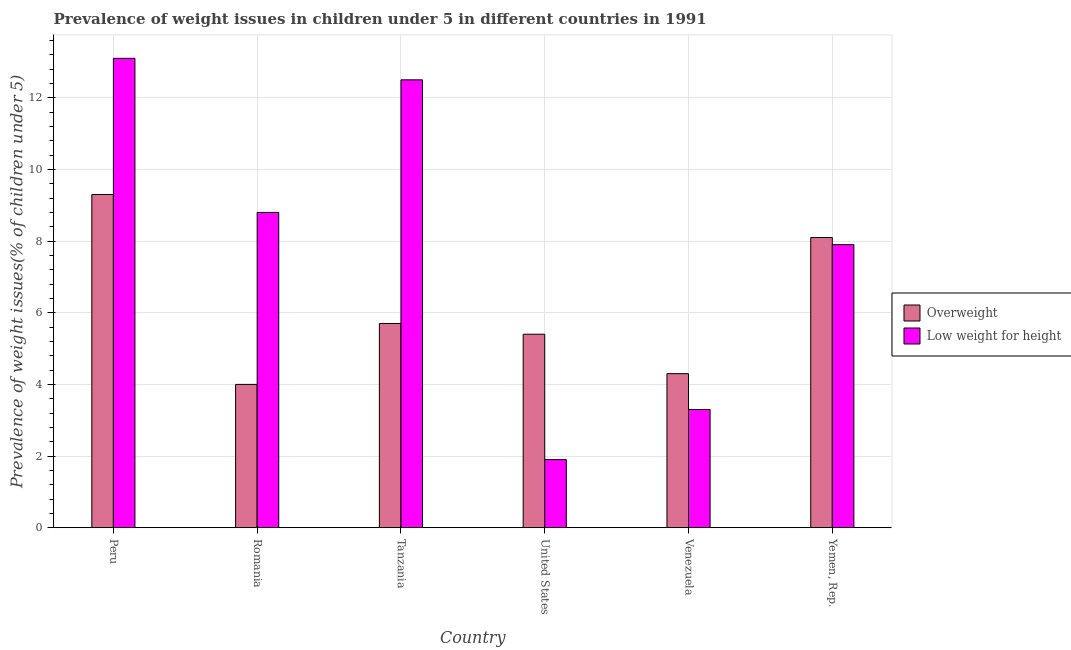How many different coloured bars are there?
Offer a terse response. 2. How many groups of bars are there?
Your response must be concise. 6. Are the number of bars per tick equal to the number of legend labels?
Your answer should be compact. Yes. Are the number of bars on each tick of the X-axis equal?
Your answer should be very brief. Yes. How many bars are there on the 1st tick from the right?
Your answer should be compact. 2. What is the label of the 6th group of bars from the left?
Keep it short and to the point. Yemen, Rep. In how many cases, is the number of bars for a given country not equal to the number of legend labels?
Your response must be concise. 0. What is the percentage of underweight children in Yemen, Rep.?
Your response must be concise. 7.9. Across all countries, what is the maximum percentage of overweight children?
Ensure brevity in your answer.  9.3. Across all countries, what is the minimum percentage of underweight children?
Ensure brevity in your answer.  1.9. In which country was the percentage of overweight children minimum?
Provide a short and direct response. Romania. What is the total percentage of underweight children in the graph?
Your answer should be very brief. 47.5. What is the difference between the percentage of underweight children in Romania and that in Tanzania?
Your answer should be very brief. -3.7. What is the difference between the percentage of overweight children in Peru and the percentage of underweight children in Yemen, Rep.?
Offer a terse response. 1.4. What is the average percentage of underweight children per country?
Offer a very short reply. 7.92. What is the difference between the percentage of underweight children and percentage of overweight children in Tanzania?
Make the answer very short. 6.8. What is the ratio of the percentage of overweight children in Romania to that in Tanzania?
Ensure brevity in your answer.  0.7. What is the difference between the highest and the second highest percentage of underweight children?
Provide a succinct answer. 0.6. What is the difference between the highest and the lowest percentage of overweight children?
Offer a very short reply. 5.3. What does the 1st bar from the left in United States represents?
Ensure brevity in your answer.  Overweight. What does the 1st bar from the right in Romania represents?
Keep it short and to the point. Low weight for height. How many bars are there?
Offer a terse response. 12. Are all the bars in the graph horizontal?
Make the answer very short. No. What is the difference between two consecutive major ticks on the Y-axis?
Make the answer very short. 2. Are the values on the major ticks of Y-axis written in scientific E-notation?
Give a very brief answer. No. Does the graph contain grids?
Offer a terse response. Yes. Where does the legend appear in the graph?
Give a very brief answer. Center right. How many legend labels are there?
Your answer should be compact. 2. How are the legend labels stacked?
Give a very brief answer. Vertical. What is the title of the graph?
Offer a terse response. Prevalence of weight issues in children under 5 in different countries in 1991. What is the label or title of the X-axis?
Keep it short and to the point. Country. What is the label or title of the Y-axis?
Make the answer very short. Prevalence of weight issues(% of children under 5). What is the Prevalence of weight issues(% of children under 5) in Overweight in Peru?
Your answer should be compact. 9.3. What is the Prevalence of weight issues(% of children under 5) of Low weight for height in Peru?
Give a very brief answer. 13.1. What is the Prevalence of weight issues(% of children under 5) in Low weight for height in Romania?
Ensure brevity in your answer.  8.8. What is the Prevalence of weight issues(% of children under 5) of Overweight in Tanzania?
Provide a succinct answer. 5.7. What is the Prevalence of weight issues(% of children under 5) in Low weight for height in Tanzania?
Keep it short and to the point. 12.5. What is the Prevalence of weight issues(% of children under 5) in Overweight in United States?
Offer a very short reply. 5.4. What is the Prevalence of weight issues(% of children under 5) in Low weight for height in United States?
Make the answer very short. 1.9. What is the Prevalence of weight issues(% of children under 5) in Overweight in Venezuela?
Make the answer very short. 4.3. What is the Prevalence of weight issues(% of children under 5) in Low weight for height in Venezuela?
Provide a succinct answer. 3.3. What is the Prevalence of weight issues(% of children under 5) in Overweight in Yemen, Rep.?
Your answer should be very brief. 8.1. What is the Prevalence of weight issues(% of children under 5) of Low weight for height in Yemen, Rep.?
Provide a succinct answer. 7.9. Across all countries, what is the maximum Prevalence of weight issues(% of children under 5) in Overweight?
Your response must be concise. 9.3. Across all countries, what is the maximum Prevalence of weight issues(% of children under 5) in Low weight for height?
Provide a short and direct response. 13.1. Across all countries, what is the minimum Prevalence of weight issues(% of children under 5) in Low weight for height?
Offer a very short reply. 1.9. What is the total Prevalence of weight issues(% of children under 5) in Overweight in the graph?
Provide a short and direct response. 36.8. What is the total Prevalence of weight issues(% of children under 5) in Low weight for height in the graph?
Keep it short and to the point. 47.5. What is the difference between the Prevalence of weight issues(% of children under 5) in Overweight in Peru and that in Romania?
Your answer should be compact. 5.3. What is the difference between the Prevalence of weight issues(% of children under 5) in Overweight in Peru and that in United States?
Keep it short and to the point. 3.9. What is the difference between the Prevalence of weight issues(% of children under 5) of Low weight for height in Peru and that in Yemen, Rep.?
Provide a short and direct response. 5.2. What is the difference between the Prevalence of weight issues(% of children under 5) in Overweight in Romania and that in Tanzania?
Keep it short and to the point. -1.7. What is the difference between the Prevalence of weight issues(% of children under 5) of Overweight in Romania and that in United States?
Provide a succinct answer. -1.4. What is the difference between the Prevalence of weight issues(% of children under 5) of Low weight for height in Romania and that in United States?
Your answer should be compact. 6.9. What is the difference between the Prevalence of weight issues(% of children under 5) in Overweight in Romania and that in Venezuela?
Keep it short and to the point. -0.3. What is the difference between the Prevalence of weight issues(% of children under 5) of Low weight for height in Romania and that in Yemen, Rep.?
Your response must be concise. 0.9. What is the difference between the Prevalence of weight issues(% of children under 5) of Low weight for height in Tanzania and that in Venezuela?
Keep it short and to the point. 9.2. What is the difference between the Prevalence of weight issues(% of children under 5) of Low weight for height in United States and that in Venezuela?
Your answer should be compact. -1.4. What is the difference between the Prevalence of weight issues(% of children under 5) of Overweight in United States and that in Yemen, Rep.?
Offer a terse response. -2.7. What is the difference between the Prevalence of weight issues(% of children under 5) in Overweight in Venezuela and that in Yemen, Rep.?
Keep it short and to the point. -3.8. What is the difference between the Prevalence of weight issues(% of children under 5) of Low weight for height in Venezuela and that in Yemen, Rep.?
Ensure brevity in your answer.  -4.6. What is the difference between the Prevalence of weight issues(% of children under 5) in Overweight in Peru and the Prevalence of weight issues(% of children under 5) in Low weight for height in Romania?
Keep it short and to the point. 0.5. What is the difference between the Prevalence of weight issues(% of children under 5) in Overweight in Tanzania and the Prevalence of weight issues(% of children under 5) in Low weight for height in Venezuela?
Provide a short and direct response. 2.4. What is the difference between the Prevalence of weight issues(% of children under 5) in Overweight in Tanzania and the Prevalence of weight issues(% of children under 5) in Low weight for height in Yemen, Rep.?
Your answer should be very brief. -2.2. What is the difference between the Prevalence of weight issues(% of children under 5) in Overweight in United States and the Prevalence of weight issues(% of children under 5) in Low weight for height in Venezuela?
Ensure brevity in your answer.  2.1. What is the difference between the Prevalence of weight issues(% of children under 5) in Overweight in United States and the Prevalence of weight issues(% of children under 5) in Low weight for height in Yemen, Rep.?
Provide a succinct answer. -2.5. What is the average Prevalence of weight issues(% of children under 5) of Overweight per country?
Offer a very short reply. 6.13. What is the average Prevalence of weight issues(% of children under 5) of Low weight for height per country?
Your response must be concise. 7.92. What is the difference between the Prevalence of weight issues(% of children under 5) of Overweight and Prevalence of weight issues(% of children under 5) of Low weight for height in Peru?
Give a very brief answer. -3.8. What is the difference between the Prevalence of weight issues(% of children under 5) of Overweight and Prevalence of weight issues(% of children under 5) of Low weight for height in United States?
Your answer should be very brief. 3.5. What is the difference between the Prevalence of weight issues(% of children under 5) of Overweight and Prevalence of weight issues(% of children under 5) of Low weight for height in Venezuela?
Keep it short and to the point. 1. What is the ratio of the Prevalence of weight issues(% of children under 5) in Overweight in Peru to that in Romania?
Your answer should be very brief. 2.33. What is the ratio of the Prevalence of weight issues(% of children under 5) in Low weight for height in Peru to that in Romania?
Make the answer very short. 1.49. What is the ratio of the Prevalence of weight issues(% of children under 5) in Overweight in Peru to that in Tanzania?
Your answer should be very brief. 1.63. What is the ratio of the Prevalence of weight issues(% of children under 5) of Low weight for height in Peru to that in Tanzania?
Ensure brevity in your answer.  1.05. What is the ratio of the Prevalence of weight issues(% of children under 5) in Overweight in Peru to that in United States?
Your answer should be compact. 1.72. What is the ratio of the Prevalence of weight issues(% of children under 5) of Low weight for height in Peru to that in United States?
Your response must be concise. 6.89. What is the ratio of the Prevalence of weight issues(% of children under 5) in Overweight in Peru to that in Venezuela?
Ensure brevity in your answer.  2.16. What is the ratio of the Prevalence of weight issues(% of children under 5) in Low weight for height in Peru to that in Venezuela?
Give a very brief answer. 3.97. What is the ratio of the Prevalence of weight issues(% of children under 5) of Overweight in Peru to that in Yemen, Rep.?
Your response must be concise. 1.15. What is the ratio of the Prevalence of weight issues(% of children under 5) of Low weight for height in Peru to that in Yemen, Rep.?
Keep it short and to the point. 1.66. What is the ratio of the Prevalence of weight issues(% of children under 5) of Overweight in Romania to that in Tanzania?
Your answer should be compact. 0.7. What is the ratio of the Prevalence of weight issues(% of children under 5) of Low weight for height in Romania to that in Tanzania?
Ensure brevity in your answer.  0.7. What is the ratio of the Prevalence of weight issues(% of children under 5) in Overweight in Romania to that in United States?
Give a very brief answer. 0.74. What is the ratio of the Prevalence of weight issues(% of children under 5) of Low weight for height in Romania to that in United States?
Offer a terse response. 4.63. What is the ratio of the Prevalence of weight issues(% of children under 5) of Overweight in Romania to that in Venezuela?
Ensure brevity in your answer.  0.93. What is the ratio of the Prevalence of weight issues(% of children under 5) of Low weight for height in Romania to that in Venezuela?
Provide a short and direct response. 2.67. What is the ratio of the Prevalence of weight issues(% of children under 5) of Overweight in Romania to that in Yemen, Rep.?
Offer a terse response. 0.49. What is the ratio of the Prevalence of weight issues(% of children under 5) in Low weight for height in Romania to that in Yemen, Rep.?
Give a very brief answer. 1.11. What is the ratio of the Prevalence of weight issues(% of children under 5) in Overweight in Tanzania to that in United States?
Give a very brief answer. 1.06. What is the ratio of the Prevalence of weight issues(% of children under 5) in Low weight for height in Tanzania to that in United States?
Keep it short and to the point. 6.58. What is the ratio of the Prevalence of weight issues(% of children under 5) of Overweight in Tanzania to that in Venezuela?
Provide a succinct answer. 1.33. What is the ratio of the Prevalence of weight issues(% of children under 5) of Low weight for height in Tanzania to that in Venezuela?
Provide a short and direct response. 3.79. What is the ratio of the Prevalence of weight issues(% of children under 5) in Overweight in Tanzania to that in Yemen, Rep.?
Offer a terse response. 0.7. What is the ratio of the Prevalence of weight issues(% of children under 5) of Low weight for height in Tanzania to that in Yemen, Rep.?
Provide a succinct answer. 1.58. What is the ratio of the Prevalence of weight issues(% of children under 5) in Overweight in United States to that in Venezuela?
Make the answer very short. 1.26. What is the ratio of the Prevalence of weight issues(% of children under 5) in Low weight for height in United States to that in Venezuela?
Give a very brief answer. 0.58. What is the ratio of the Prevalence of weight issues(% of children under 5) of Overweight in United States to that in Yemen, Rep.?
Offer a very short reply. 0.67. What is the ratio of the Prevalence of weight issues(% of children under 5) of Low weight for height in United States to that in Yemen, Rep.?
Your response must be concise. 0.24. What is the ratio of the Prevalence of weight issues(% of children under 5) in Overweight in Venezuela to that in Yemen, Rep.?
Provide a short and direct response. 0.53. What is the ratio of the Prevalence of weight issues(% of children under 5) in Low weight for height in Venezuela to that in Yemen, Rep.?
Keep it short and to the point. 0.42. What is the difference between the highest and the lowest Prevalence of weight issues(% of children under 5) of Overweight?
Provide a succinct answer. 5.3. 